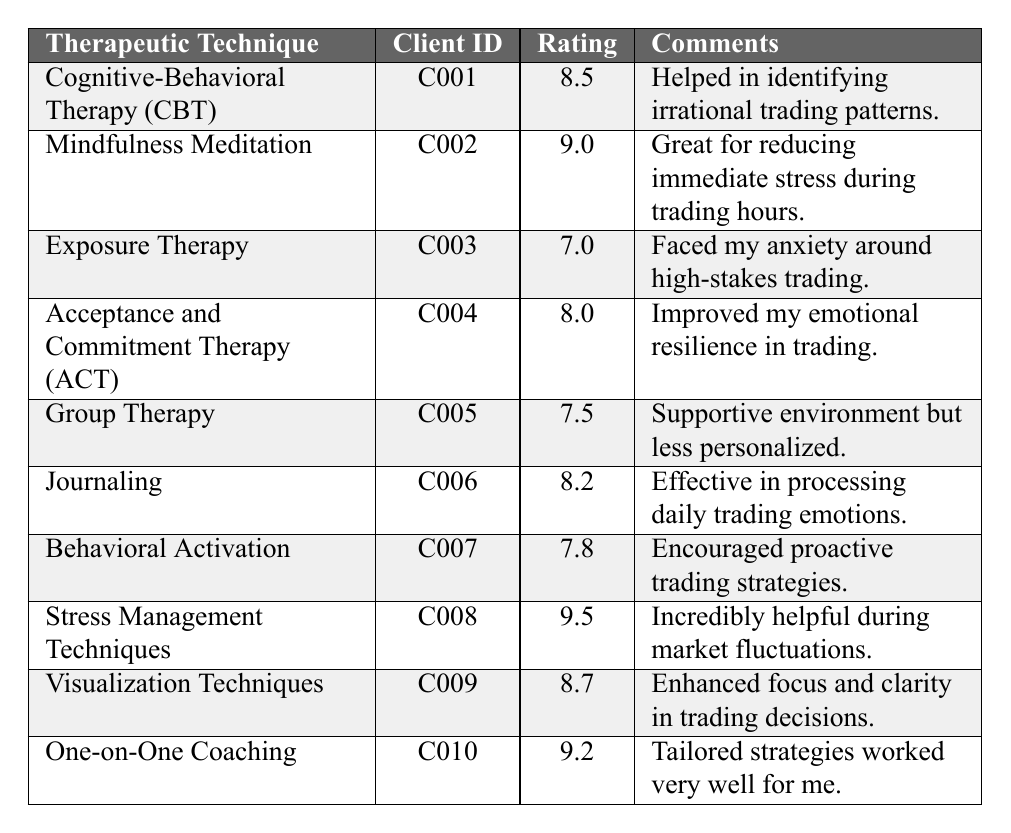What is the highest satisfaction rating among the therapeutic techniques? The table lists all satisfaction ratings, with the highest value being 9.5 for Stress Management Techniques.
Answer: 9.5 Which therapeutic technique received a satisfaction rating of 8.0? By examining the ratings in the table, Acceptance and Commitment Therapy (ACT) has a satisfaction rating of 8.0.
Answer: Acceptance and Commitment Therapy (ACT) What is the average satisfaction rating across all therapeutic techniques? First, sum the ratings: (8.5 + 9.0 + 7.0 + 8.0 + 7.5 + 8.2 + 7.8 + 9.5 + 8.7 + 9.2) = 81.4. There are 10 techniques, so the average is 81.4 / 10 = 8.14.
Answer: 8.14 Did any client give a satisfaction rating below 8.0? Reviewing the ratings, Exposure Therapy received a rating of 7.0, which is below 8.0.
Answer: Yes Which therapeutic technique has the most favorable comments? Stress Management Techniques received a very positive comment, stating it was "Incredibly helpful during market fluctuations", along with the highest rating of 9.5, indicating strong satisfaction.
Answer: Stress Management Techniques What is the difference between the highest and lowest satisfaction ratings? The highest rating is 9.5 (Stress Management Techniques) and the lowest is 7.0 (Exposure Therapy). The difference is 9.5 - 7.0 = 2.5.
Answer: 2.5 Which therapeutic techniques received ratings of 8.2 or higher? The techniques that received ratings of 8.2 or higher are Cognitive-Behavioral Therapy (CBT), Mindfulness Meditation, Acceptance and Commitment Therapy (ACT), Journaling, Stress Management Techniques, Visualization Techniques, and One-on-One Coaching.
Answer: 7 techniques Is there a technique that combines both high satisfaction and positive comments? Yes, Stress Management Techniques received a high rating of 9.5 along with a comment emphasizing its helpfulness during market fluctuations, indicating both high satisfaction and a positive comment.
Answer: Yes Which client reported using one-on-one coaching? According to the table, the client ID C010 reported using One-on-One Coaching and gave it a satisfaction rating of 9.2.
Answer: C010 What can be inferred about the effectiveness of Group Therapy based on its rating and comments? Group Therapy received a satisfaction rating of 7.5, which is moderate, and the comment mentioned that while it provided a supportive environment, it was less personalized, suggesting it may not be as effective for individual needs compared to other techniques.
Answer: Moderately effective due to less personalization 